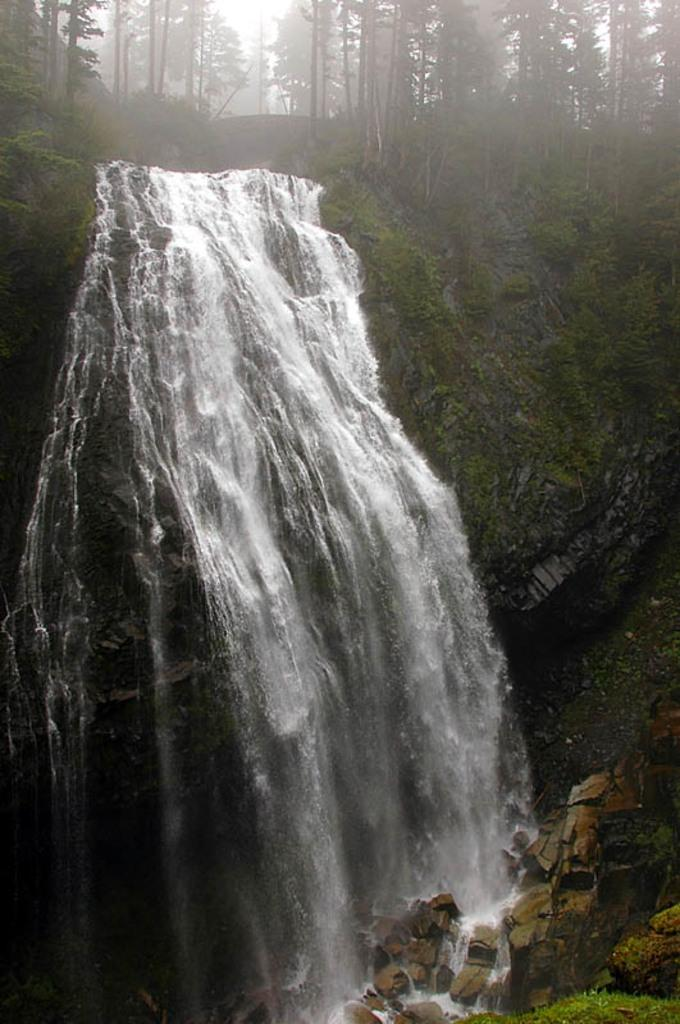What natural feature is the main subject of the image? There is a waterfall in the image. What other elements can be seen in the image? There are rocks and trees in the image. How many children are playing musical instruments near the waterfall in the image? There are no children or musical instruments present in the image. 